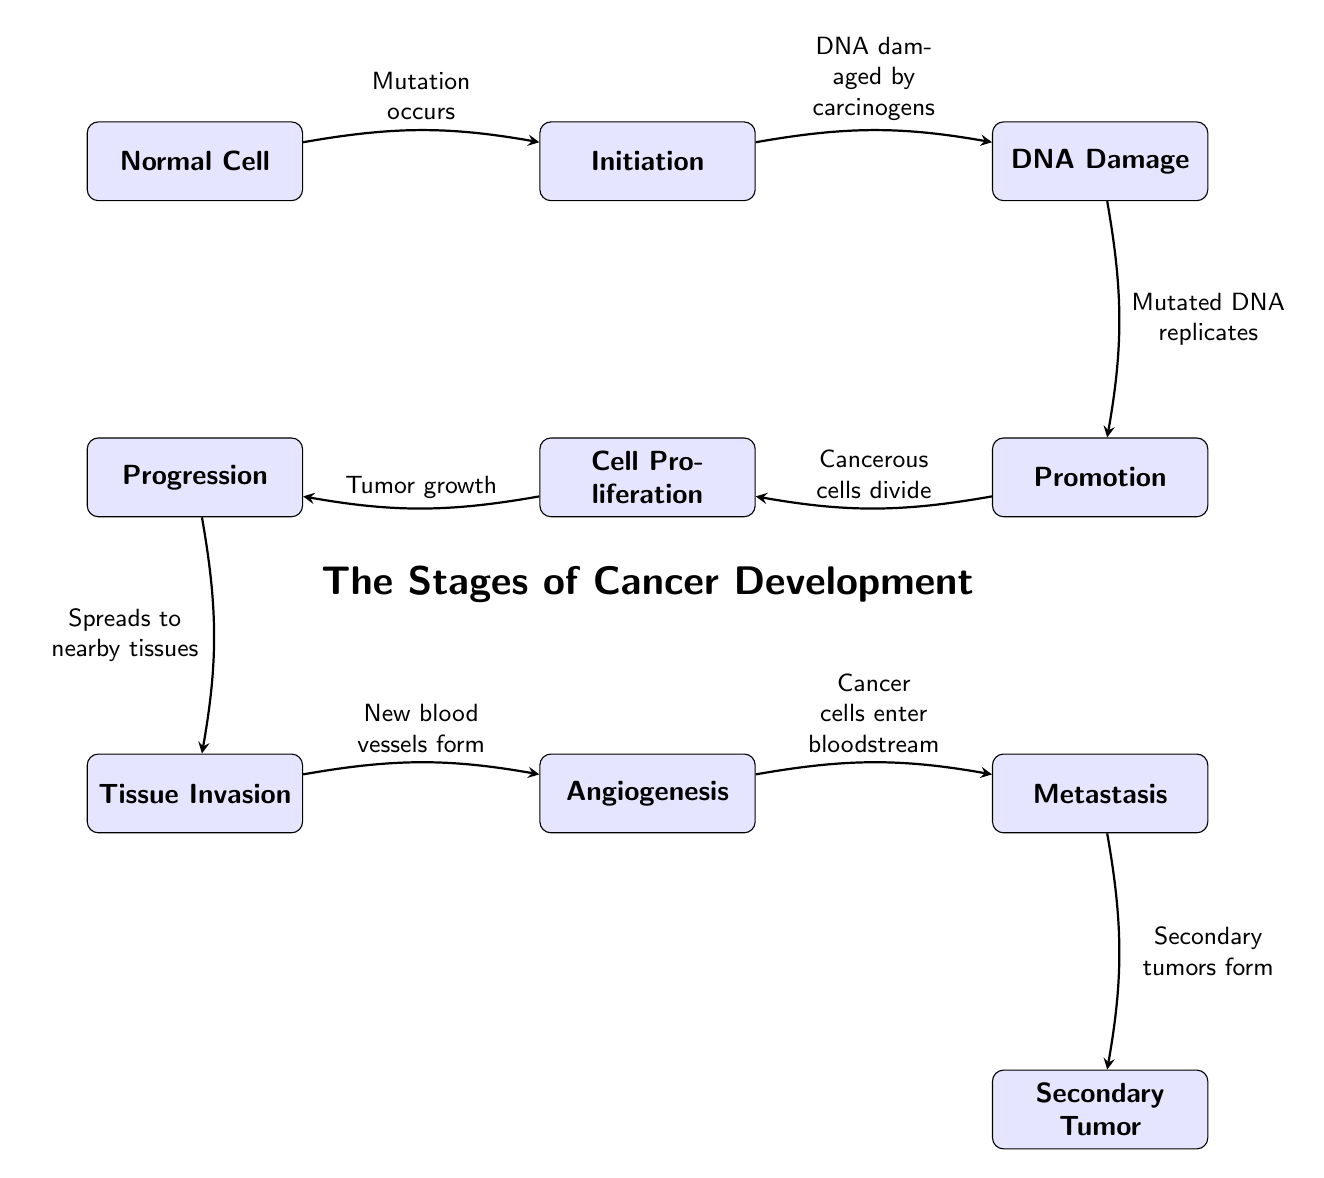What is the first stage of cancer development? The diagram indicates that the first stage of cancer development is when a normal cell undergoes mutation, leading to the "Initiation" stage.
Answer: Initiation How many stages are displayed in the diagram? The diagram shows a total of 8 stages, including the initial normal cell and the final secondary tumor. The stages are Normal Cell, Initiation, DNA Damage, Promotion, Cell Proliferation, Progression, Tissue Invasion, Angiogenesis, Metastasis, and Secondary Tumor.
Answer: 8 What happens after DNA damage? After DNA damage, the mutated DNA replicates during the "Promotion" stage, indicating that the process continues from DNA Damage to Promotion.
Answer: Mutated DNA replicates What process occurs after the Promotion stage? The Promotion stage is followed by the Cell Proliferation stage, where cancerous cells divide, leading to tumor growth. Therefore, after Promotion, the next process is Cell Proliferation.
Answer: Cell Proliferation Which stage involves new blood vessels forming? The stage that involves new blood vessels forming is "Angiogenesis". In the flow of the diagram, after Tissue Invasion, Angiogenesis is the next step that occurs.
Answer: Angiogenesis What is the relationship between Invasion and Metastasis? The relationship between Invasion and Metastasis is that during Invasion, cancer spreads to nearby tissues, and then in the Metastasis stage, cancer cells enter the bloodstream to form secondary tumors. Therefore, Invasion leads to Metastasis.
Answer: Invasion leads to Metastasis How does the cancer process begin? The cancer process begins with mutations occurring in normal cells, transitioning them into the Initiation stage. This indicates that the mutation of normal cells is the starting point.
Answer: Mutation occurs What is the final stage of cancer development shown in the diagram? The final stage of cancer development shown in the diagram is the formation of a Secondary Tumor, which occurs after Metastasis. Therefore, Secondary Tumor is the endpoint of the cancer development stages outlined in the diagram.
Answer: Secondary Tumor 